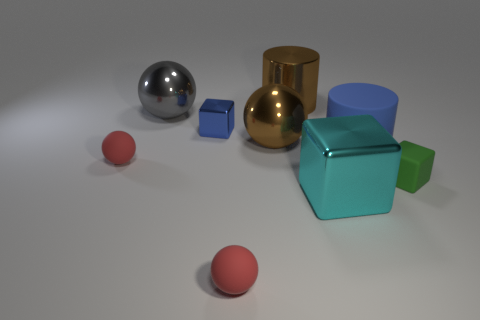Subtract all blue balls. Subtract all purple cylinders. How many balls are left? 4 Add 1 red rubber balls. How many objects exist? 10 Subtract all cylinders. How many objects are left? 7 Add 5 big shiny things. How many big shiny things exist? 9 Subtract 1 brown spheres. How many objects are left? 8 Subtract all gray shiny cylinders. Subtract all blue metal blocks. How many objects are left? 8 Add 4 spheres. How many spheres are left? 8 